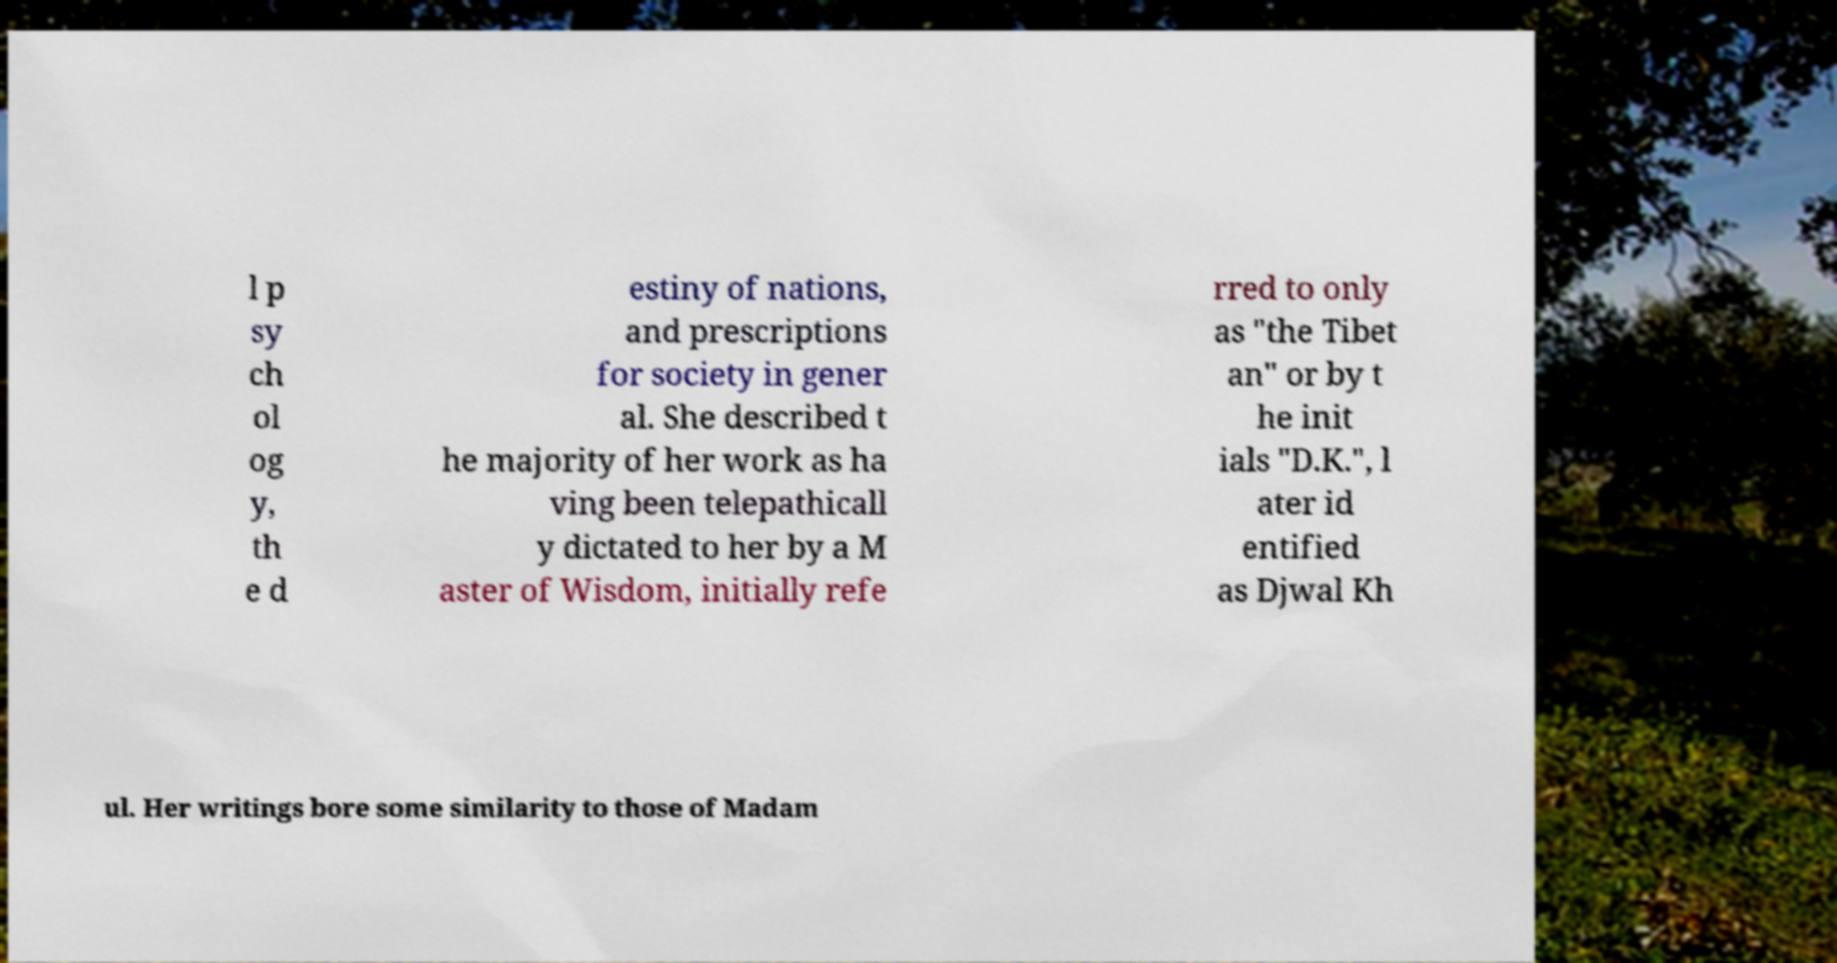Could you assist in decoding the text presented in this image and type it out clearly? l p sy ch ol og y, th e d estiny of nations, and prescriptions for society in gener al. She described t he majority of her work as ha ving been telepathicall y dictated to her by a M aster of Wisdom, initially refe rred to only as "the Tibet an" or by t he init ials "D.K.", l ater id entified as Djwal Kh ul. Her writings bore some similarity to those of Madam 